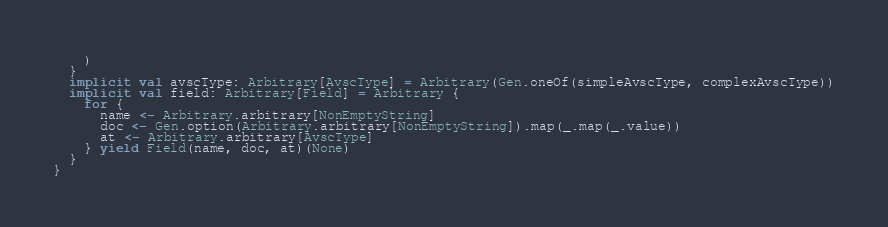<code> <loc_0><loc_0><loc_500><loc_500><_Scala_>    )
  }
  implicit val avscType: Arbitrary[AvscType] = Arbitrary(Gen.oneOf(simpleAvscType, complexAvscType))
  implicit val field: Arbitrary[Field] = Arbitrary {
    for {
      name <- Arbitrary.arbitrary[NonEmptyString]
      doc <- Gen.option(Arbitrary.arbitrary[NonEmptyString]).map(_.map(_.value))
      at <- Arbitrary.arbitrary[AvscType]
    } yield Field(name, doc, at)(None)
  }
}
</code> 